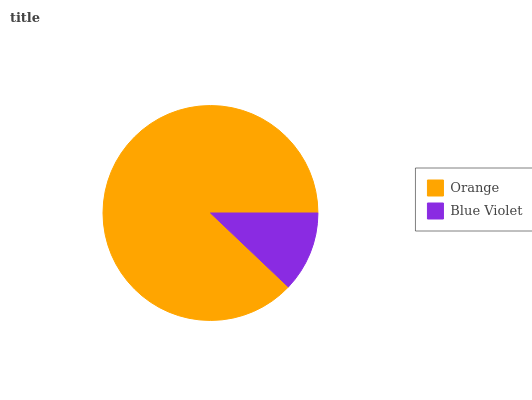Is Blue Violet the minimum?
Answer yes or no. Yes. Is Orange the maximum?
Answer yes or no. Yes. Is Blue Violet the maximum?
Answer yes or no. No. Is Orange greater than Blue Violet?
Answer yes or no. Yes. Is Blue Violet less than Orange?
Answer yes or no. Yes. Is Blue Violet greater than Orange?
Answer yes or no. No. Is Orange less than Blue Violet?
Answer yes or no. No. Is Orange the high median?
Answer yes or no. Yes. Is Blue Violet the low median?
Answer yes or no. Yes. Is Blue Violet the high median?
Answer yes or no. No. Is Orange the low median?
Answer yes or no. No. 